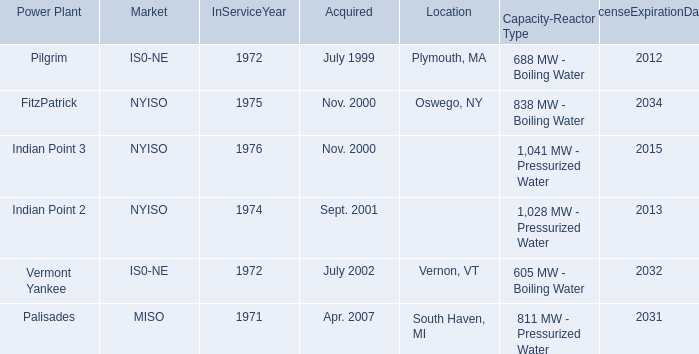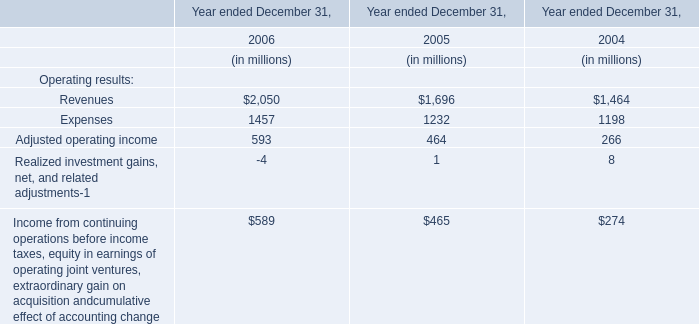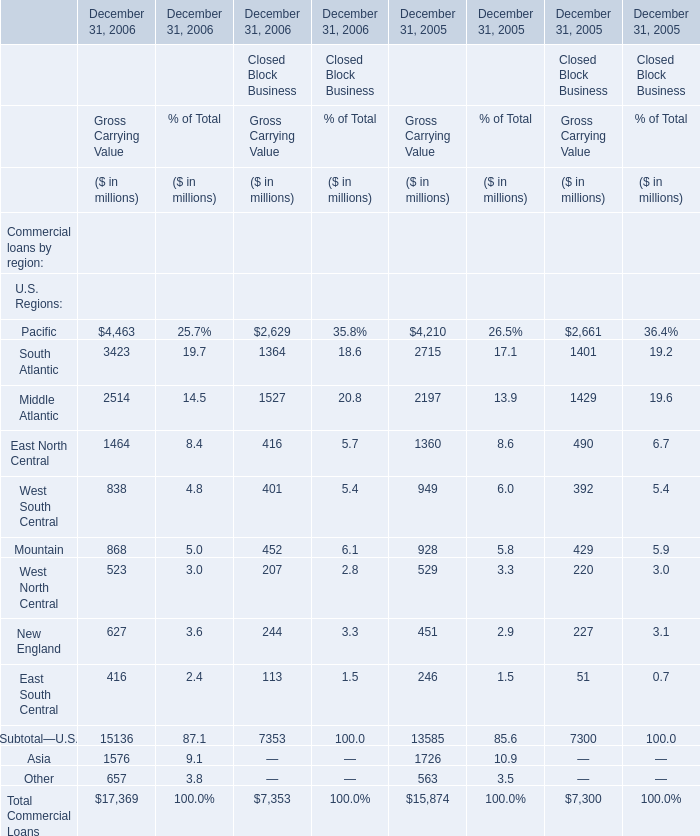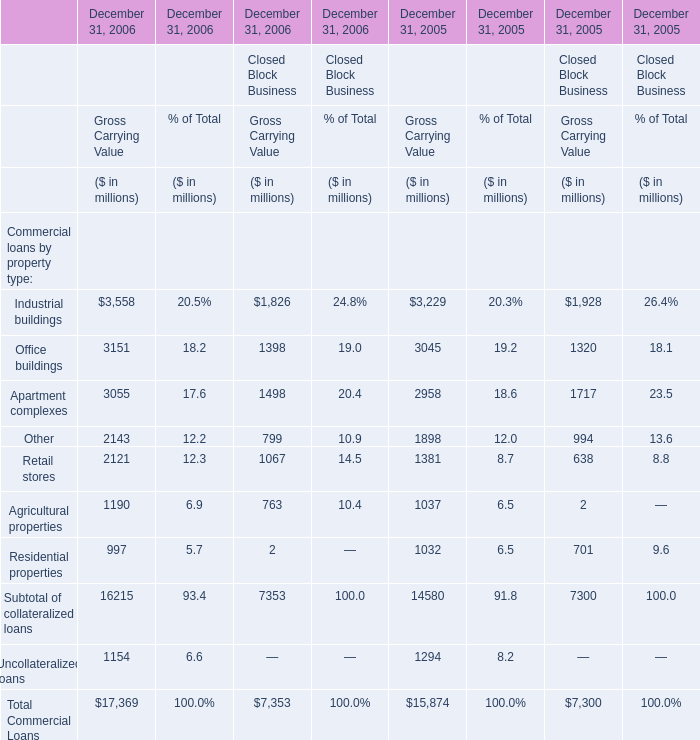In which year is South Atlantic positive for Gross Carrying Value? 
Answer: 2006 2005. 